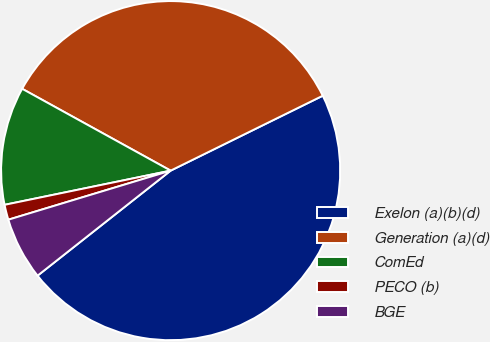<chart> <loc_0><loc_0><loc_500><loc_500><pie_chart><fcel>Exelon (a)(b)(d)<fcel>Generation (a)(d)<fcel>ComEd<fcel>PECO (b)<fcel>BGE<nl><fcel>46.65%<fcel>34.7%<fcel>11.25%<fcel>1.44%<fcel>5.96%<nl></chart> 